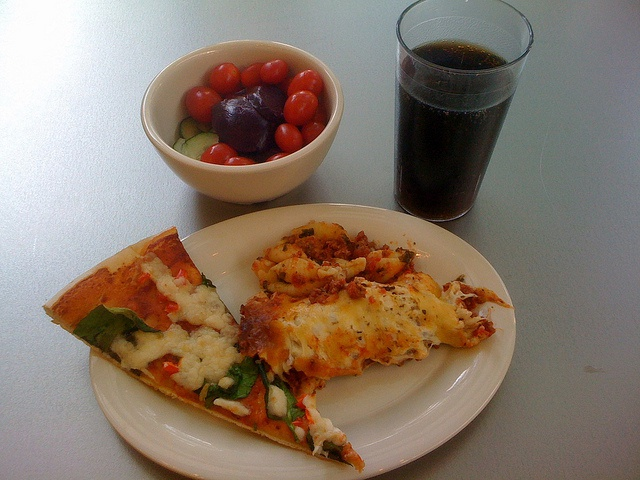Describe the objects in this image and their specific colors. I can see dining table in white, gray, lightgray, darkgray, and maroon tones, pizza in white, brown, maroon, and gray tones, pizza in white, brown, maroon, and black tones, bowl in white, maroon, gray, and black tones, and cup in white, black, and gray tones in this image. 